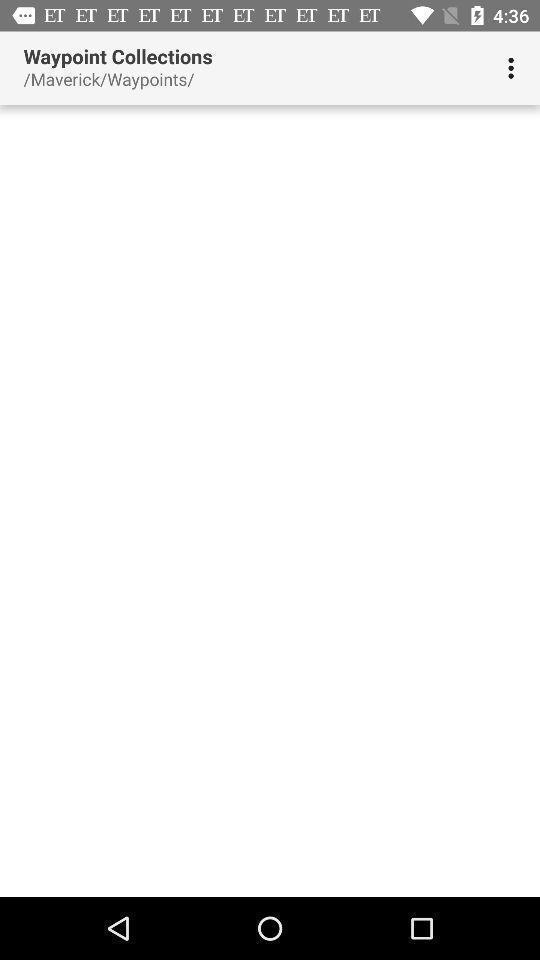Summarize the information in this screenshot. Screen shows waypoint collections page. 